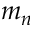Convert formula to latex. <formula><loc_0><loc_0><loc_500><loc_500>m _ { n }</formula> 